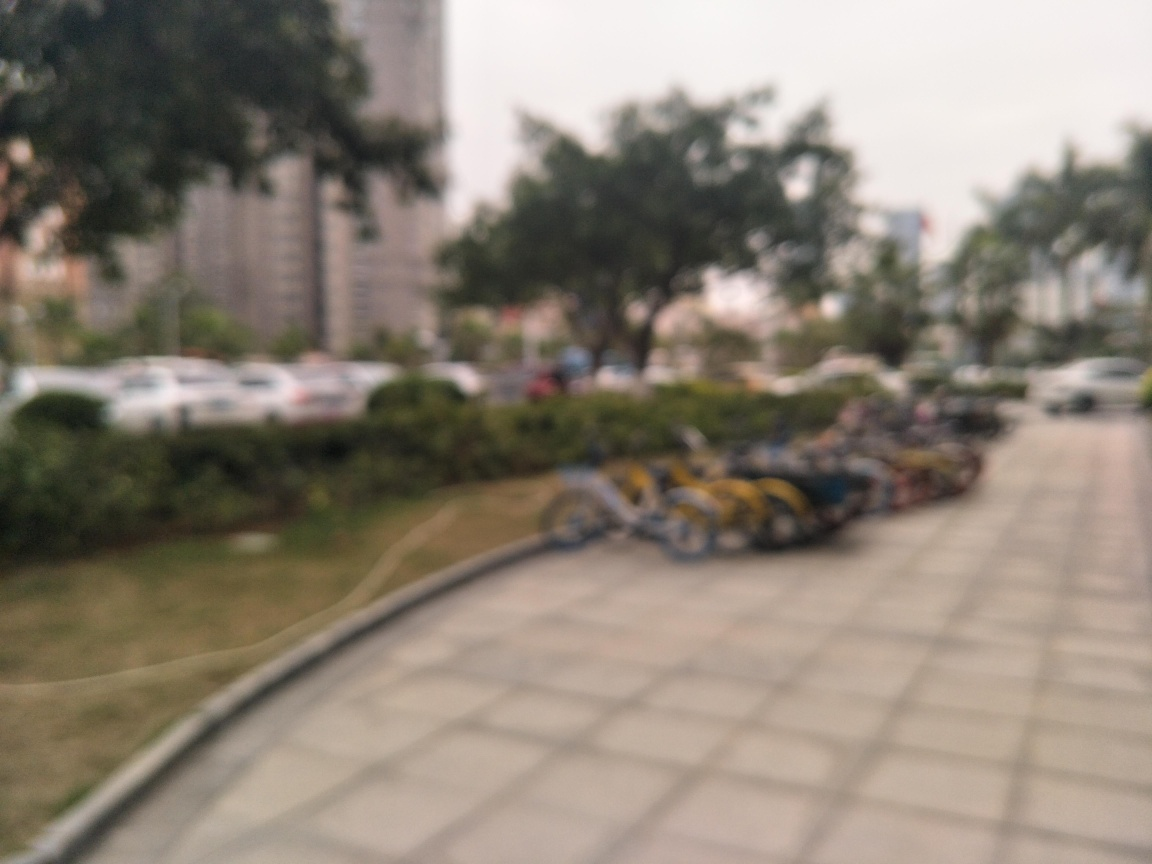Can you describe the setting of this image? The setting appears to be an outdoor urban space, perhaps a park or a street near buildings. There's a line of bicycles and cars, indicating it might be a parking area. Based on the image, what time of day do you think it is? The lighting in the image suggests it could be daytime, but due to the blurriness, it's challenging to determine the exact time. 